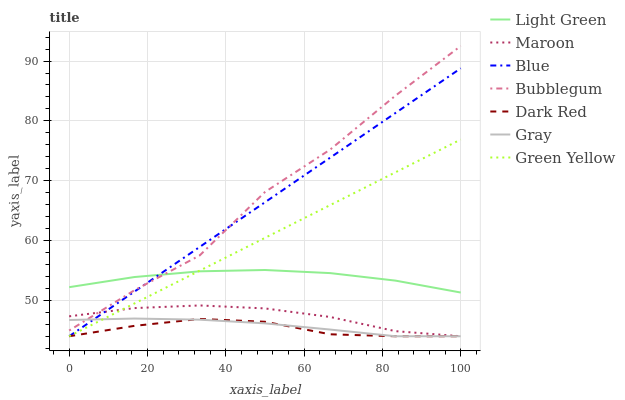Does Gray have the minimum area under the curve?
Answer yes or no. No. Does Gray have the maximum area under the curve?
Answer yes or no. No. Is Gray the smoothest?
Answer yes or no. No. Is Gray the roughest?
Answer yes or no. No. Does Bubblegum have the lowest value?
Answer yes or no. No. Does Gray have the highest value?
Answer yes or no. No. Is Dark Red less than Bubblegum?
Answer yes or no. Yes. Is Bubblegum greater than Dark Red?
Answer yes or no. Yes. Does Dark Red intersect Bubblegum?
Answer yes or no. No. 